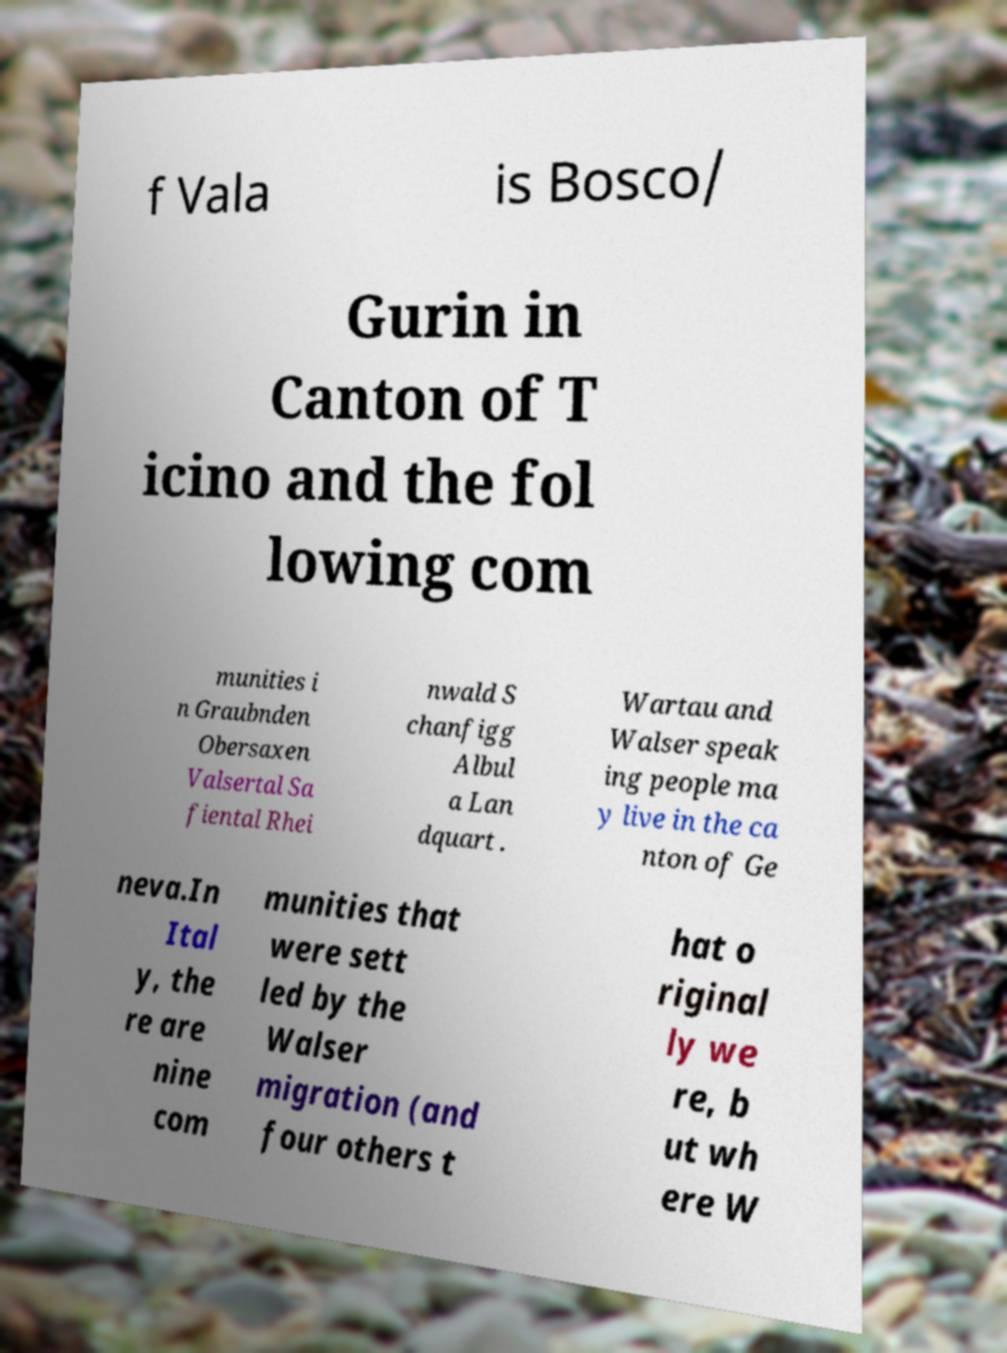Can you read and provide the text displayed in the image?This photo seems to have some interesting text. Can you extract and type it out for me? f Vala is Bosco/ Gurin in Canton of T icino and the fol lowing com munities i n Graubnden Obersaxen Valsertal Sa fiental Rhei nwald S chanfigg Albul a Lan dquart . Wartau and Walser speak ing people ma y live in the ca nton of Ge neva.In Ital y, the re are nine com munities that were sett led by the Walser migration (and four others t hat o riginal ly we re, b ut wh ere W 